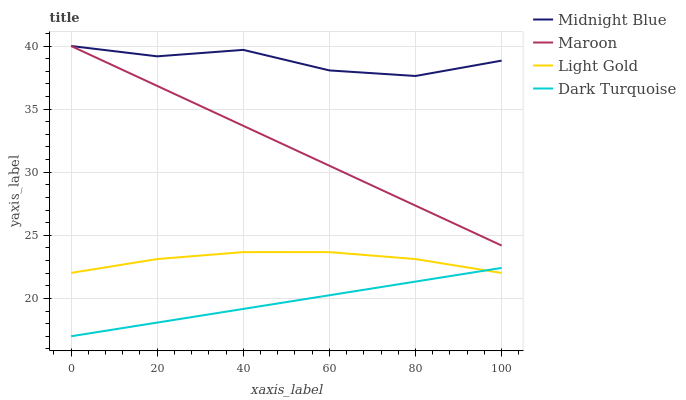Does Dark Turquoise have the minimum area under the curve?
Answer yes or no. Yes. Does Midnight Blue have the maximum area under the curve?
Answer yes or no. Yes. Does Light Gold have the minimum area under the curve?
Answer yes or no. No. Does Light Gold have the maximum area under the curve?
Answer yes or no. No. Is Dark Turquoise the smoothest?
Answer yes or no. Yes. Is Midnight Blue the roughest?
Answer yes or no. Yes. Is Light Gold the smoothest?
Answer yes or no. No. Is Light Gold the roughest?
Answer yes or no. No. Does Dark Turquoise have the lowest value?
Answer yes or no. Yes. Does Light Gold have the lowest value?
Answer yes or no. No. Does Maroon have the highest value?
Answer yes or no. Yes. Does Light Gold have the highest value?
Answer yes or no. No. Is Light Gold less than Maroon?
Answer yes or no. Yes. Is Maroon greater than Dark Turquoise?
Answer yes or no. Yes. Does Maroon intersect Midnight Blue?
Answer yes or no. Yes. Is Maroon less than Midnight Blue?
Answer yes or no. No. Is Maroon greater than Midnight Blue?
Answer yes or no. No. Does Light Gold intersect Maroon?
Answer yes or no. No. 